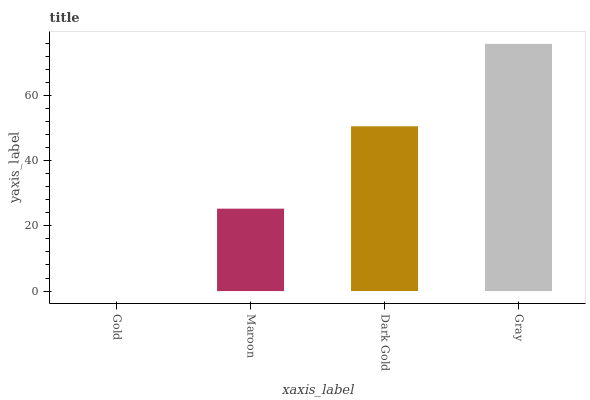Is Gold the minimum?
Answer yes or no. Yes. Is Gray the maximum?
Answer yes or no. Yes. Is Maroon the minimum?
Answer yes or no. No. Is Maroon the maximum?
Answer yes or no. No. Is Maroon greater than Gold?
Answer yes or no. Yes. Is Gold less than Maroon?
Answer yes or no. Yes. Is Gold greater than Maroon?
Answer yes or no. No. Is Maroon less than Gold?
Answer yes or no. No. Is Dark Gold the high median?
Answer yes or no. Yes. Is Maroon the low median?
Answer yes or no. Yes. Is Maroon the high median?
Answer yes or no. No. Is Gray the low median?
Answer yes or no. No. 